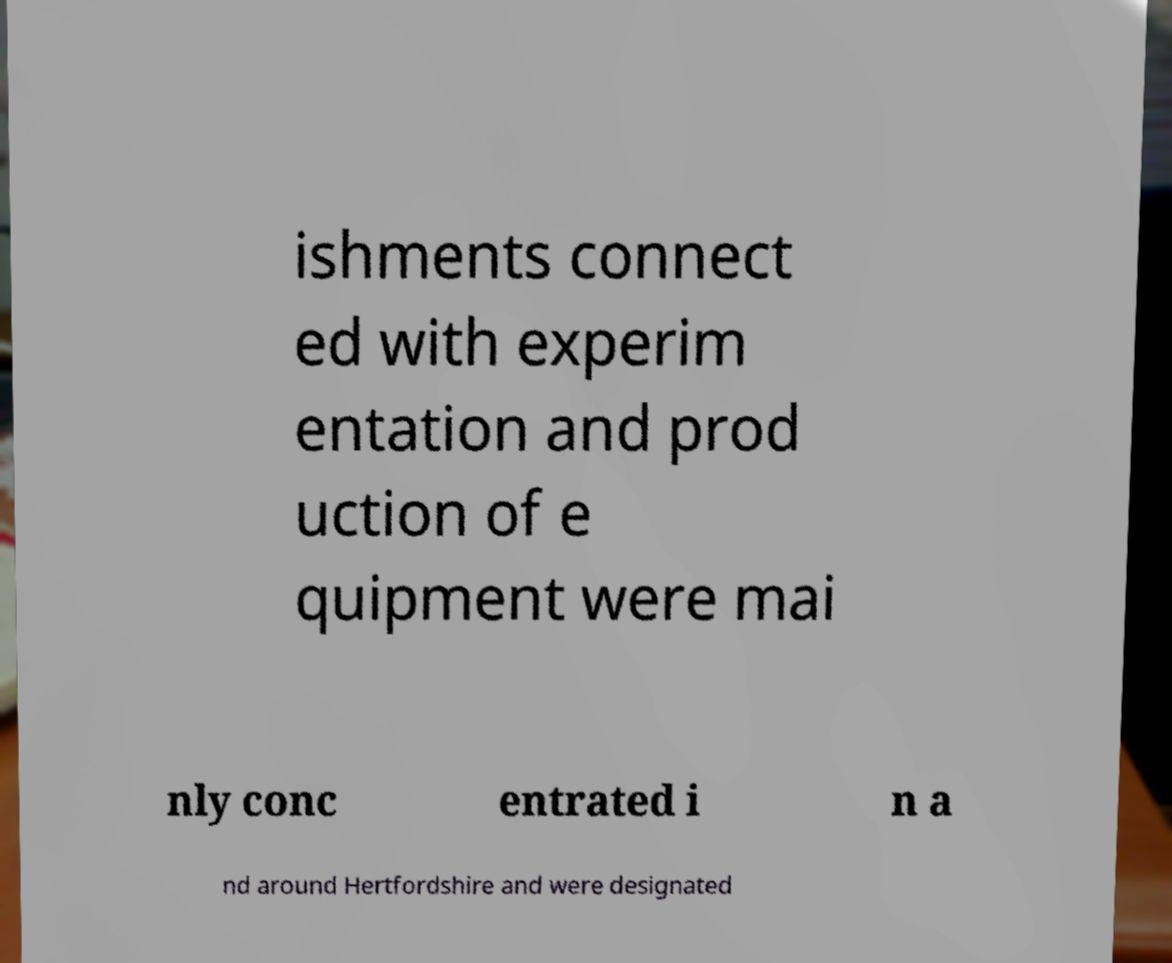Please read and relay the text visible in this image. What does it say? ishments connect ed with experim entation and prod uction of e quipment were mai nly conc entrated i n a nd around Hertfordshire and were designated 